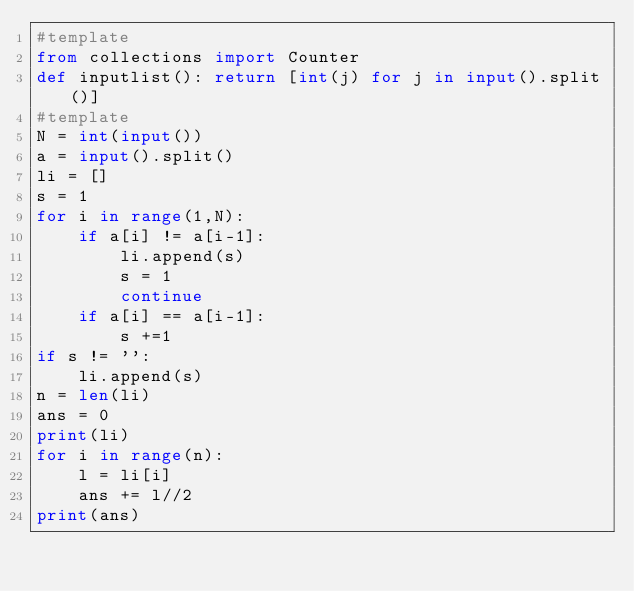Convert code to text. <code><loc_0><loc_0><loc_500><loc_500><_Python_>#template
from collections import Counter
def inputlist(): return [int(j) for j in input().split()]
#template
N = int(input())
a = input().split()
li = []
s = 1
for i in range(1,N):
    if a[i] != a[i-1]:
        li.append(s)
        s = 1
        continue
    if a[i] == a[i-1]:
        s +=1
if s != '':
    li.append(s)
n = len(li)
ans = 0
print(li)
for i in range(n):
    l = li[i]
    ans += l//2
print(ans)</code> 